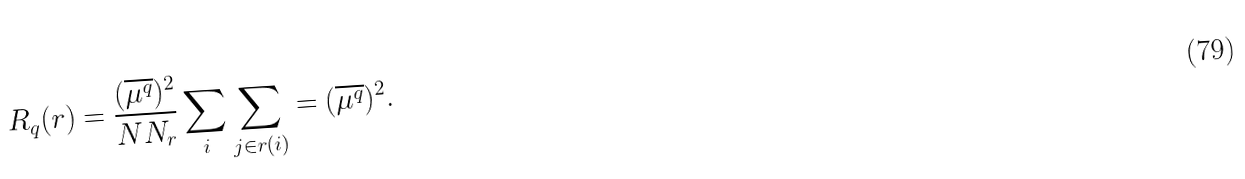Convert formula to latex. <formula><loc_0><loc_0><loc_500><loc_500>R _ { q } ( r ) = \frac { ( \overline { \mu ^ { q } } ) ^ { 2 } } { N N _ { r } } \sum _ { i } \sum _ { j \in r ( i ) } = ( \overline { \mu ^ { q } } ) ^ { 2 } .</formula> 